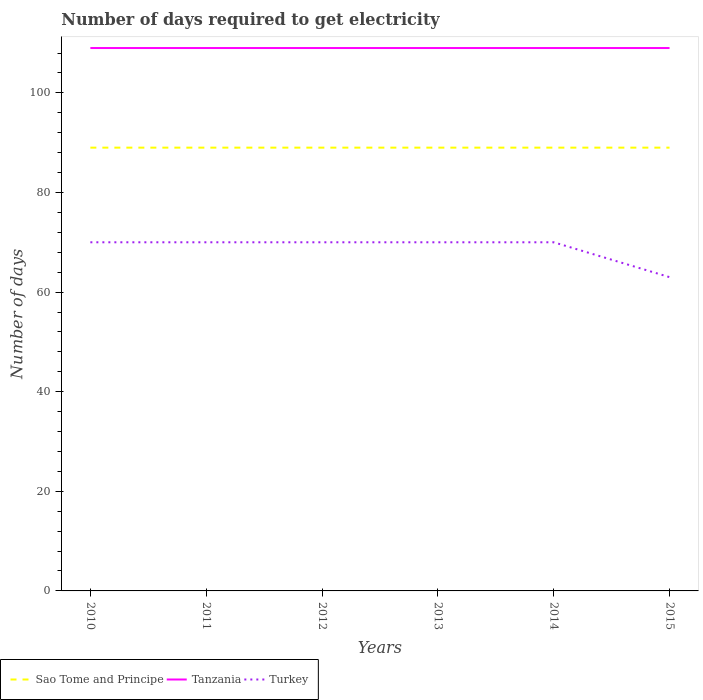Across all years, what is the maximum number of days required to get electricity in in Sao Tome and Principe?
Your response must be concise. 89. What is the total number of days required to get electricity in in Sao Tome and Principe in the graph?
Ensure brevity in your answer.  0. What is the difference between the highest and the second highest number of days required to get electricity in in Turkey?
Provide a short and direct response. 7. Is the number of days required to get electricity in in Tanzania strictly greater than the number of days required to get electricity in in Turkey over the years?
Offer a very short reply. No. How many lines are there?
Offer a terse response. 3. Does the graph contain any zero values?
Your answer should be very brief. No. Does the graph contain grids?
Provide a short and direct response. No. Where does the legend appear in the graph?
Offer a very short reply. Bottom left. How are the legend labels stacked?
Offer a terse response. Horizontal. What is the title of the graph?
Ensure brevity in your answer.  Number of days required to get electricity. What is the label or title of the X-axis?
Provide a short and direct response. Years. What is the label or title of the Y-axis?
Offer a very short reply. Number of days. What is the Number of days in Sao Tome and Principe in 2010?
Offer a very short reply. 89. What is the Number of days of Tanzania in 2010?
Ensure brevity in your answer.  109. What is the Number of days of Sao Tome and Principe in 2011?
Provide a short and direct response. 89. What is the Number of days of Tanzania in 2011?
Offer a very short reply. 109. What is the Number of days of Turkey in 2011?
Your answer should be very brief. 70. What is the Number of days of Sao Tome and Principe in 2012?
Your answer should be very brief. 89. What is the Number of days of Tanzania in 2012?
Keep it short and to the point. 109. What is the Number of days of Turkey in 2012?
Provide a succinct answer. 70. What is the Number of days of Sao Tome and Principe in 2013?
Your response must be concise. 89. What is the Number of days in Tanzania in 2013?
Give a very brief answer. 109. What is the Number of days in Sao Tome and Principe in 2014?
Provide a short and direct response. 89. What is the Number of days in Tanzania in 2014?
Your answer should be compact. 109. What is the Number of days of Turkey in 2014?
Give a very brief answer. 70. What is the Number of days in Sao Tome and Principe in 2015?
Offer a terse response. 89. What is the Number of days in Tanzania in 2015?
Make the answer very short. 109. What is the Number of days of Turkey in 2015?
Offer a very short reply. 63. Across all years, what is the maximum Number of days of Sao Tome and Principe?
Provide a short and direct response. 89. Across all years, what is the maximum Number of days in Tanzania?
Keep it short and to the point. 109. Across all years, what is the minimum Number of days of Sao Tome and Principe?
Offer a very short reply. 89. Across all years, what is the minimum Number of days in Tanzania?
Keep it short and to the point. 109. Across all years, what is the minimum Number of days in Turkey?
Keep it short and to the point. 63. What is the total Number of days in Sao Tome and Principe in the graph?
Keep it short and to the point. 534. What is the total Number of days in Tanzania in the graph?
Offer a very short reply. 654. What is the total Number of days of Turkey in the graph?
Keep it short and to the point. 413. What is the difference between the Number of days in Sao Tome and Principe in 2010 and that in 2011?
Provide a short and direct response. 0. What is the difference between the Number of days of Tanzania in 2010 and that in 2011?
Your answer should be very brief. 0. What is the difference between the Number of days of Turkey in 2010 and that in 2012?
Your answer should be very brief. 0. What is the difference between the Number of days of Sao Tome and Principe in 2010 and that in 2013?
Your answer should be very brief. 0. What is the difference between the Number of days in Tanzania in 2010 and that in 2013?
Offer a terse response. 0. What is the difference between the Number of days of Turkey in 2010 and that in 2013?
Your response must be concise. 0. What is the difference between the Number of days of Tanzania in 2010 and that in 2014?
Give a very brief answer. 0. What is the difference between the Number of days in Tanzania in 2010 and that in 2015?
Provide a succinct answer. 0. What is the difference between the Number of days in Turkey in 2010 and that in 2015?
Give a very brief answer. 7. What is the difference between the Number of days of Turkey in 2011 and that in 2012?
Offer a terse response. 0. What is the difference between the Number of days in Turkey in 2011 and that in 2013?
Keep it short and to the point. 0. What is the difference between the Number of days in Sao Tome and Principe in 2011 and that in 2014?
Ensure brevity in your answer.  0. What is the difference between the Number of days of Turkey in 2011 and that in 2015?
Ensure brevity in your answer.  7. What is the difference between the Number of days in Tanzania in 2012 and that in 2013?
Your answer should be compact. 0. What is the difference between the Number of days in Sao Tome and Principe in 2012 and that in 2014?
Your answer should be very brief. 0. What is the difference between the Number of days of Turkey in 2012 and that in 2014?
Provide a short and direct response. 0. What is the difference between the Number of days of Sao Tome and Principe in 2012 and that in 2015?
Offer a terse response. 0. What is the difference between the Number of days in Turkey in 2012 and that in 2015?
Make the answer very short. 7. What is the difference between the Number of days in Sao Tome and Principe in 2013 and that in 2014?
Your answer should be very brief. 0. What is the difference between the Number of days of Tanzania in 2013 and that in 2014?
Provide a short and direct response. 0. What is the difference between the Number of days in Turkey in 2013 and that in 2014?
Provide a succinct answer. 0. What is the difference between the Number of days of Turkey in 2013 and that in 2015?
Provide a succinct answer. 7. What is the difference between the Number of days in Tanzania in 2014 and that in 2015?
Your answer should be very brief. 0. What is the difference between the Number of days in Sao Tome and Principe in 2010 and the Number of days in Tanzania in 2011?
Keep it short and to the point. -20. What is the difference between the Number of days of Sao Tome and Principe in 2010 and the Number of days of Turkey in 2012?
Provide a succinct answer. 19. What is the difference between the Number of days in Tanzania in 2010 and the Number of days in Turkey in 2012?
Provide a succinct answer. 39. What is the difference between the Number of days of Sao Tome and Principe in 2010 and the Number of days of Turkey in 2013?
Offer a terse response. 19. What is the difference between the Number of days of Tanzania in 2010 and the Number of days of Turkey in 2014?
Make the answer very short. 39. What is the difference between the Number of days in Tanzania in 2010 and the Number of days in Turkey in 2015?
Provide a succinct answer. 46. What is the difference between the Number of days in Sao Tome and Principe in 2011 and the Number of days in Tanzania in 2012?
Offer a terse response. -20. What is the difference between the Number of days in Tanzania in 2011 and the Number of days in Turkey in 2012?
Make the answer very short. 39. What is the difference between the Number of days of Sao Tome and Principe in 2011 and the Number of days of Turkey in 2013?
Offer a terse response. 19. What is the difference between the Number of days in Sao Tome and Principe in 2011 and the Number of days in Tanzania in 2014?
Ensure brevity in your answer.  -20. What is the difference between the Number of days in Sao Tome and Principe in 2011 and the Number of days in Turkey in 2014?
Your answer should be compact. 19. What is the difference between the Number of days of Sao Tome and Principe in 2011 and the Number of days of Tanzania in 2015?
Offer a very short reply. -20. What is the difference between the Number of days of Sao Tome and Principe in 2011 and the Number of days of Turkey in 2015?
Provide a succinct answer. 26. What is the difference between the Number of days of Tanzania in 2011 and the Number of days of Turkey in 2015?
Provide a succinct answer. 46. What is the difference between the Number of days in Sao Tome and Principe in 2012 and the Number of days in Tanzania in 2013?
Your answer should be compact. -20. What is the difference between the Number of days of Tanzania in 2012 and the Number of days of Turkey in 2013?
Offer a terse response. 39. What is the difference between the Number of days of Sao Tome and Principe in 2012 and the Number of days of Turkey in 2014?
Offer a terse response. 19. What is the difference between the Number of days of Tanzania in 2012 and the Number of days of Turkey in 2014?
Give a very brief answer. 39. What is the difference between the Number of days in Sao Tome and Principe in 2012 and the Number of days in Turkey in 2015?
Offer a terse response. 26. What is the difference between the Number of days in Sao Tome and Principe in 2013 and the Number of days in Tanzania in 2014?
Your response must be concise. -20. What is the difference between the Number of days of Sao Tome and Principe in 2013 and the Number of days of Tanzania in 2015?
Provide a short and direct response. -20. What is the difference between the Number of days in Sao Tome and Principe in 2013 and the Number of days in Turkey in 2015?
Provide a succinct answer. 26. What is the difference between the Number of days in Sao Tome and Principe in 2014 and the Number of days in Tanzania in 2015?
Keep it short and to the point. -20. What is the difference between the Number of days in Sao Tome and Principe in 2014 and the Number of days in Turkey in 2015?
Your answer should be compact. 26. What is the difference between the Number of days in Tanzania in 2014 and the Number of days in Turkey in 2015?
Your response must be concise. 46. What is the average Number of days of Sao Tome and Principe per year?
Offer a terse response. 89. What is the average Number of days of Tanzania per year?
Give a very brief answer. 109. What is the average Number of days of Turkey per year?
Offer a very short reply. 68.83. In the year 2010, what is the difference between the Number of days in Sao Tome and Principe and Number of days in Tanzania?
Ensure brevity in your answer.  -20. In the year 2010, what is the difference between the Number of days in Sao Tome and Principe and Number of days in Turkey?
Provide a short and direct response. 19. In the year 2011, what is the difference between the Number of days in Sao Tome and Principe and Number of days in Turkey?
Offer a very short reply. 19. In the year 2011, what is the difference between the Number of days in Tanzania and Number of days in Turkey?
Your answer should be compact. 39. In the year 2012, what is the difference between the Number of days of Sao Tome and Principe and Number of days of Turkey?
Provide a succinct answer. 19. In the year 2013, what is the difference between the Number of days in Sao Tome and Principe and Number of days in Tanzania?
Make the answer very short. -20. In the year 2013, what is the difference between the Number of days of Sao Tome and Principe and Number of days of Turkey?
Provide a succinct answer. 19. In the year 2014, what is the difference between the Number of days of Sao Tome and Principe and Number of days of Turkey?
Ensure brevity in your answer.  19. What is the ratio of the Number of days of Sao Tome and Principe in 2010 to that in 2011?
Ensure brevity in your answer.  1. What is the ratio of the Number of days in Tanzania in 2010 to that in 2011?
Ensure brevity in your answer.  1. What is the ratio of the Number of days of Sao Tome and Principe in 2010 to that in 2012?
Give a very brief answer. 1. What is the ratio of the Number of days of Turkey in 2010 to that in 2012?
Provide a succinct answer. 1. What is the ratio of the Number of days in Turkey in 2010 to that in 2013?
Your response must be concise. 1. What is the ratio of the Number of days in Sao Tome and Principe in 2010 to that in 2014?
Provide a succinct answer. 1. What is the ratio of the Number of days of Turkey in 2010 to that in 2014?
Ensure brevity in your answer.  1. What is the ratio of the Number of days of Sao Tome and Principe in 2010 to that in 2015?
Your response must be concise. 1. What is the ratio of the Number of days in Tanzania in 2010 to that in 2015?
Offer a very short reply. 1. What is the ratio of the Number of days of Sao Tome and Principe in 2011 to that in 2012?
Your answer should be compact. 1. What is the ratio of the Number of days of Tanzania in 2011 to that in 2013?
Your answer should be very brief. 1. What is the ratio of the Number of days in Turkey in 2011 to that in 2013?
Keep it short and to the point. 1. What is the ratio of the Number of days of Sao Tome and Principe in 2011 to that in 2014?
Provide a short and direct response. 1. What is the ratio of the Number of days of Turkey in 2011 to that in 2014?
Make the answer very short. 1. What is the ratio of the Number of days in Tanzania in 2011 to that in 2015?
Keep it short and to the point. 1. What is the ratio of the Number of days in Tanzania in 2012 to that in 2013?
Offer a terse response. 1. What is the ratio of the Number of days in Turkey in 2012 to that in 2013?
Give a very brief answer. 1. What is the ratio of the Number of days in Sao Tome and Principe in 2012 to that in 2014?
Your answer should be compact. 1. What is the ratio of the Number of days in Turkey in 2012 to that in 2014?
Ensure brevity in your answer.  1. What is the ratio of the Number of days of Sao Tome and Principe in 2012 to that in 2015?
Ensure brevity in your answer.  1. What is the ratio of the Number of days of Turkey in 2012 to that in 2015?
Your response must be concise. 1.11. What is the ratio of the Number of days in Tanzania in 2013 to that in 2014?
Your answer should be compact. 1. What is the ratio of the Number of days in Sao Tome and Principe in 2014 to that in 2015?
Give a very brief answer. 1. What is the ratio of the Number of days of Turkey in 2014 to that in 2015?
Ensure brevity in your answer.  1.11. What is the difference between the highest and the lowest Number of days in Sao Tome and Principe?
Give a very brief answer. 0. What is the difference between the highest and the lowest Number of days in Tanzania?
Make the answer very short. 0. What is the difference between the highest and the lowest Number of days in Turkey?
Make the answer very short. 7. 